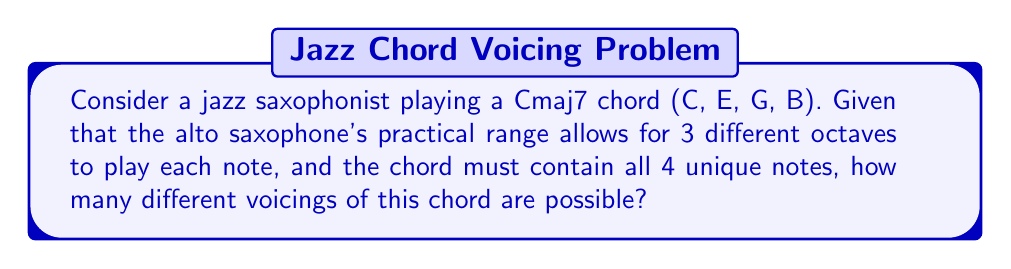Help me with this question. Let's approach this step-by-step:

1) First, we need to understand what we're counting. We're looking for the number of ways to choose one octave for each of the 4 notes in the Cmaj7 chord.

2) For each note, we have 3 choices of octaves. This is true for all 4 notes independently.

3) This scenario is a perfect application of the multiplication principle. When we have a series of independent choices, we multiply the number of options for each choice.

4) Therefore, we can express this mathematically as:

   $$ 3 \times 3 \times 3 \times 3 = 3^4 $$

5) This is because we're making 4 independent choices (one for each note in the chord), and each choice has 3 options (the 3 possible octaves).

6) Calculating this:

   $$ 3^4 = 3 \times 3 \times 3 \times 3 = 81 $$

Thus, there are 81 possible voicings for this chord within the given constraints.
Answer: 81 